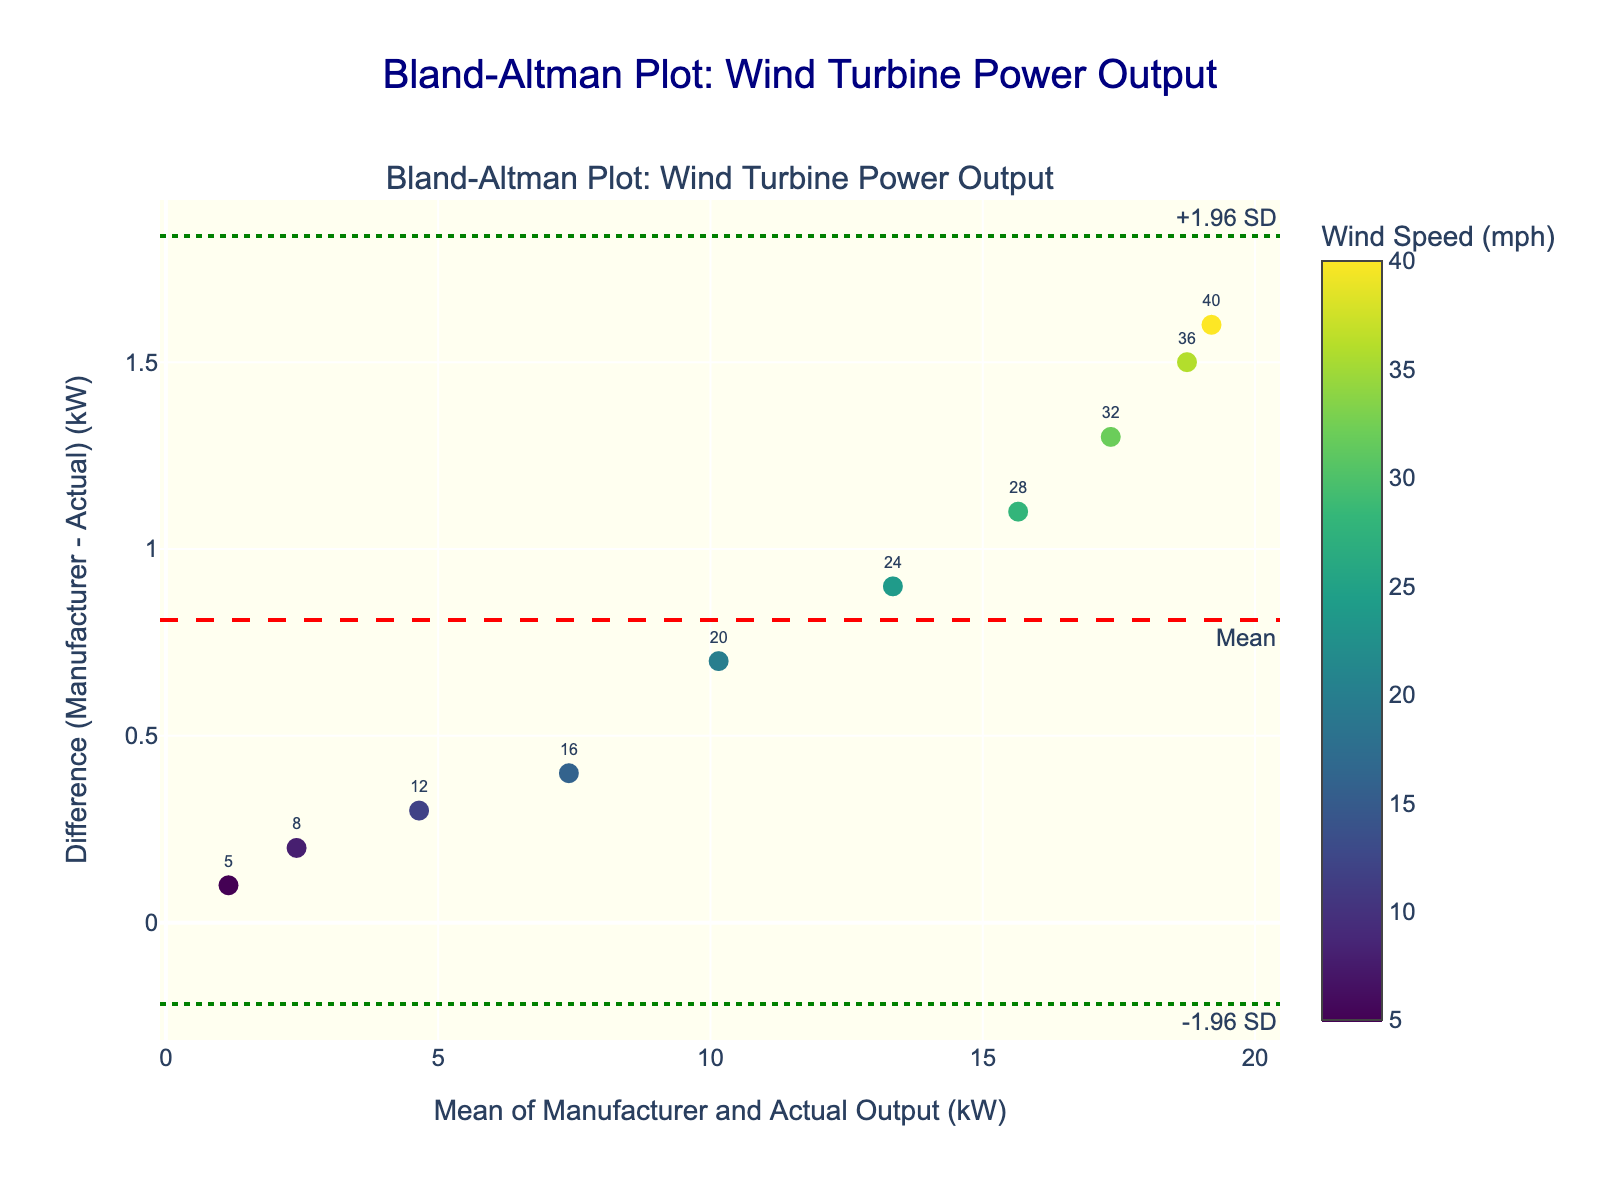What is the title of the plot? The title is written at the top of the plot and it reads "Bland-Altman Plot: Wind Turbine Power Output".
Answer: Bland-Altman Plot: Wind Turbine Power Output What are the labels for the x-axis and y-axis? The labels can be found along the respective axes. The x-axis is labeled 'Mean of Manufacturer and Actual Output (kW)' and the y-axis is labeled 'Difference (Manufacturer - Actual) (kW)'.
Answer: Mean of Manufacturer and Actual Output (kW) / Difference (Manufacturer - Actual) (kW) How many data points are displayed in the plot? By counting all the markers present in the plot, we find that there are 10 data points.
Answer: 10 Which color scale is used for the data points, and what does it represent? The color scale for the data points is shown as 'Viridis'. The color bar on the right side indicates that the scale represents Wind Speed in mph.
Answer: Viridis / Wind Speed (mph) What is the mean difference between the manufacturer and actual output? The mean difference is indicated by the red dashed line on the plot, annotated as 'Mean'.
Answer: Mean What are the values of the upper and lower limits of agreement? The upper limit of agreement is annotated as '+1.96 SD' and the lower limit as '-1.96 SD' on the plot. These lines are green and dotted.
Answer: +1.96 SD / -1.96 SD Which data point has the highest wind speed, and what is its difference value? By looking at the color and the annotated text, the data point with the highest wind speed has a wind speed of 40 mph. The corresponding difference value can be read directly from the y-axis at that point which is -1.6 kW.
Answer: 40 mph / -1.6 kW Which data point has the largest positive difference, and what is the wind speed at that point? The largest positive difference is the highest point on the y-axis. By checking the plot, we see it's approximately 0.9 kW for a wind speed of 5 mph.
Answer: 0.9 kW / 5 mph Which data point has the largest negative difference, and what is the mean output at that point? The largest negative difference is the lowest point on the y-axis. According to the plot, this value is approximately -1.6 kW, and the corresponding mean output is around 19.2 kW.
Answer: -1.6 kW / 19.2 kW For data points with a mean output between 14 and 20 kW, what's the range of differences? Identify data points within the x-axis range of 14 to 20 kW, then look at their y-axis values for the differences. The range of differences here spans from approximately -0.9 to -0.7 kW.
Answer: -0.9 to -0.7 kW 